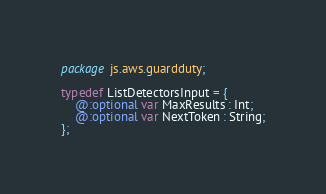<code> <loc_0><loc_0><loc_500><loc_500><_Haxe_>package js.aws.guardduty;

typedef ListDetectorsInput = {
    @:optional var MaxResults : Int;
    @:optional var NextToken : String;
};
</code> 